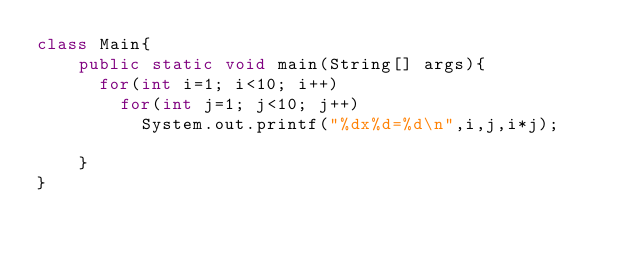<code> <loc_0><loc_0><loc_500><loc_500><_Java_>class Main{
    public static void main(String[] args){
    	for(int i=1; i<10; i++)
    		for(int j=1; j<10; j++)
    			System.out.printf("%dx%d=%d\n",i,j,i*j);
    	
    }
}</code> 